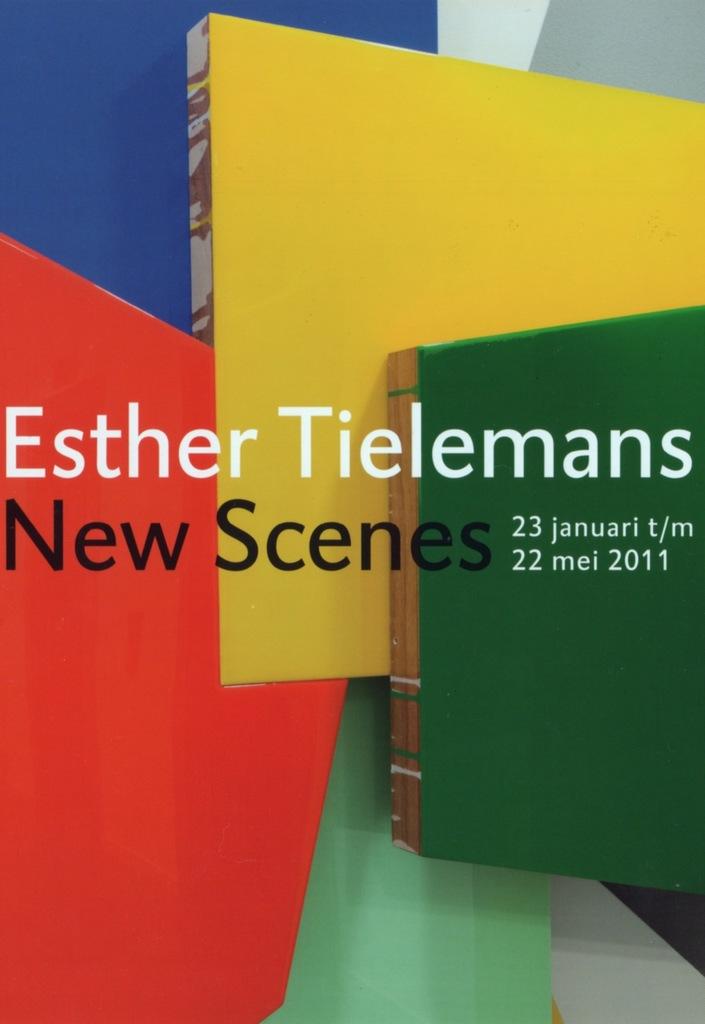What is the title of this book?
Your answer should be compact. New scenes. 